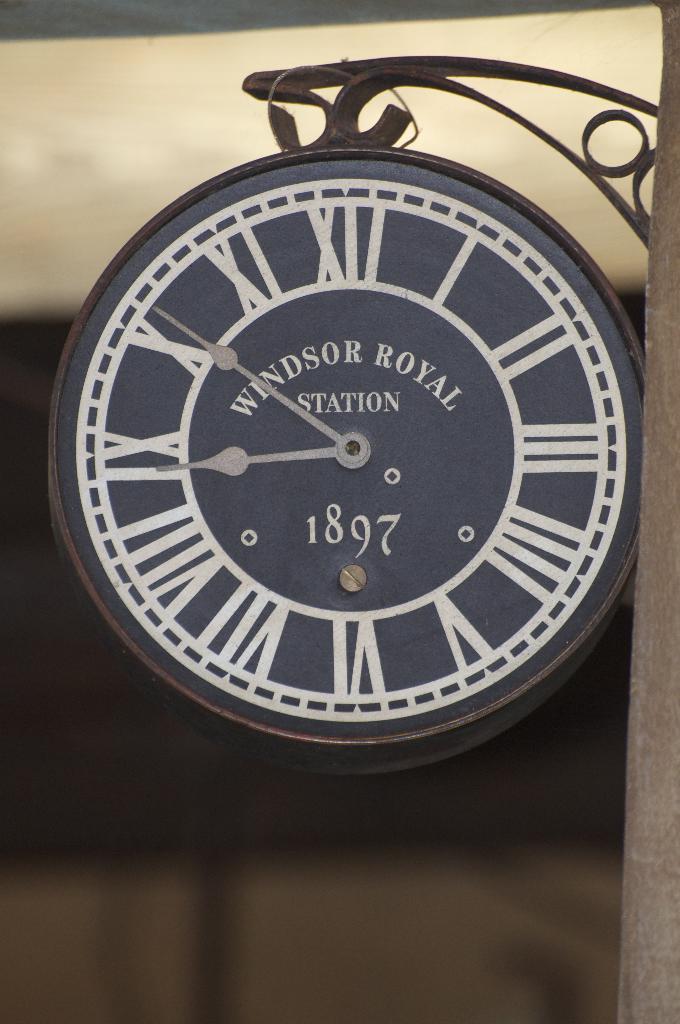What year was this clock made?
Provide a succinct answer. 1897. 